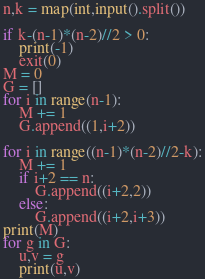Convert code to text. <code><loc_0><loc_0><loc_500><loc_500><_Python_>n,k = map(int,input().split())

if k-(n-1)*(n-2)//2 > 0:
    print(-1)
    exit(0)
M = 0
G = []
for i in range(n-1):
    M += 1
    G.append((1,i+2))

for i in range((n-1)*(n-2)//2-k):
    M += 1
    if i+2 == n:
        G.append((i+2,2))
    else:
        G.append((i+2,i+3))
print(M)
for g in G:
    u,v = g
    print(u,v)
</code> 